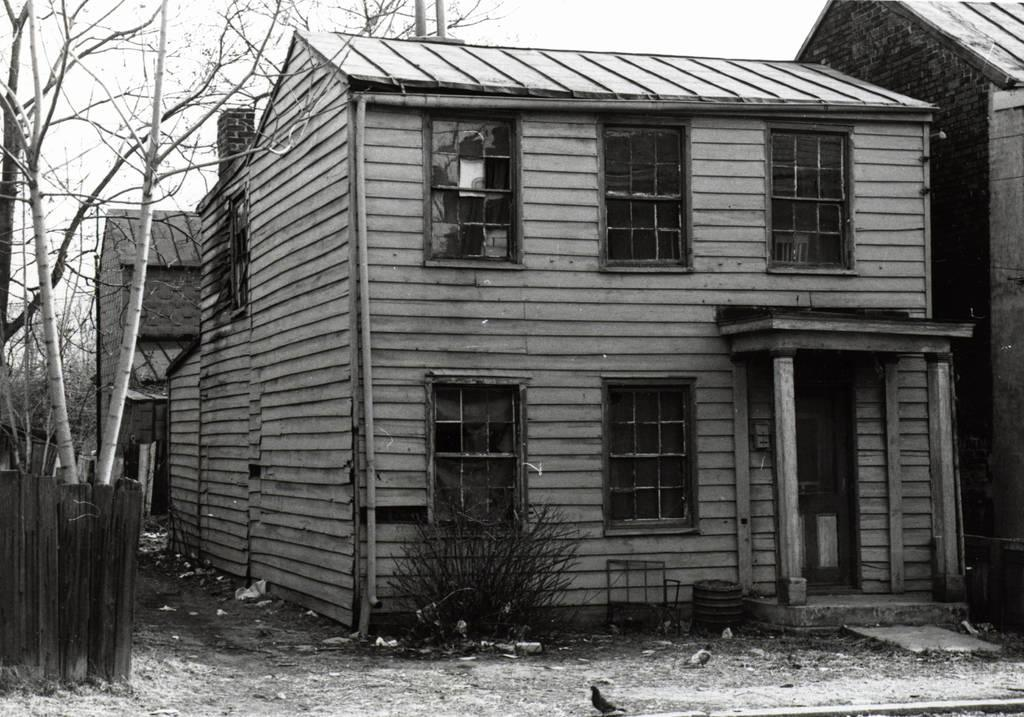What type of structures can be seen in the image? There are houses in the image. What feature is present on the houses? There are windows visible in the image. What type of vegetation is present in the image? There are plants in the image. What type of barrier can be seen in the image? There is a fence in the image. What is visible in the background of the image? The sky is visible in the image. What type of mark can be seen on the bird in the image? There is no bird present in the image, so there is no mark to be seen. 